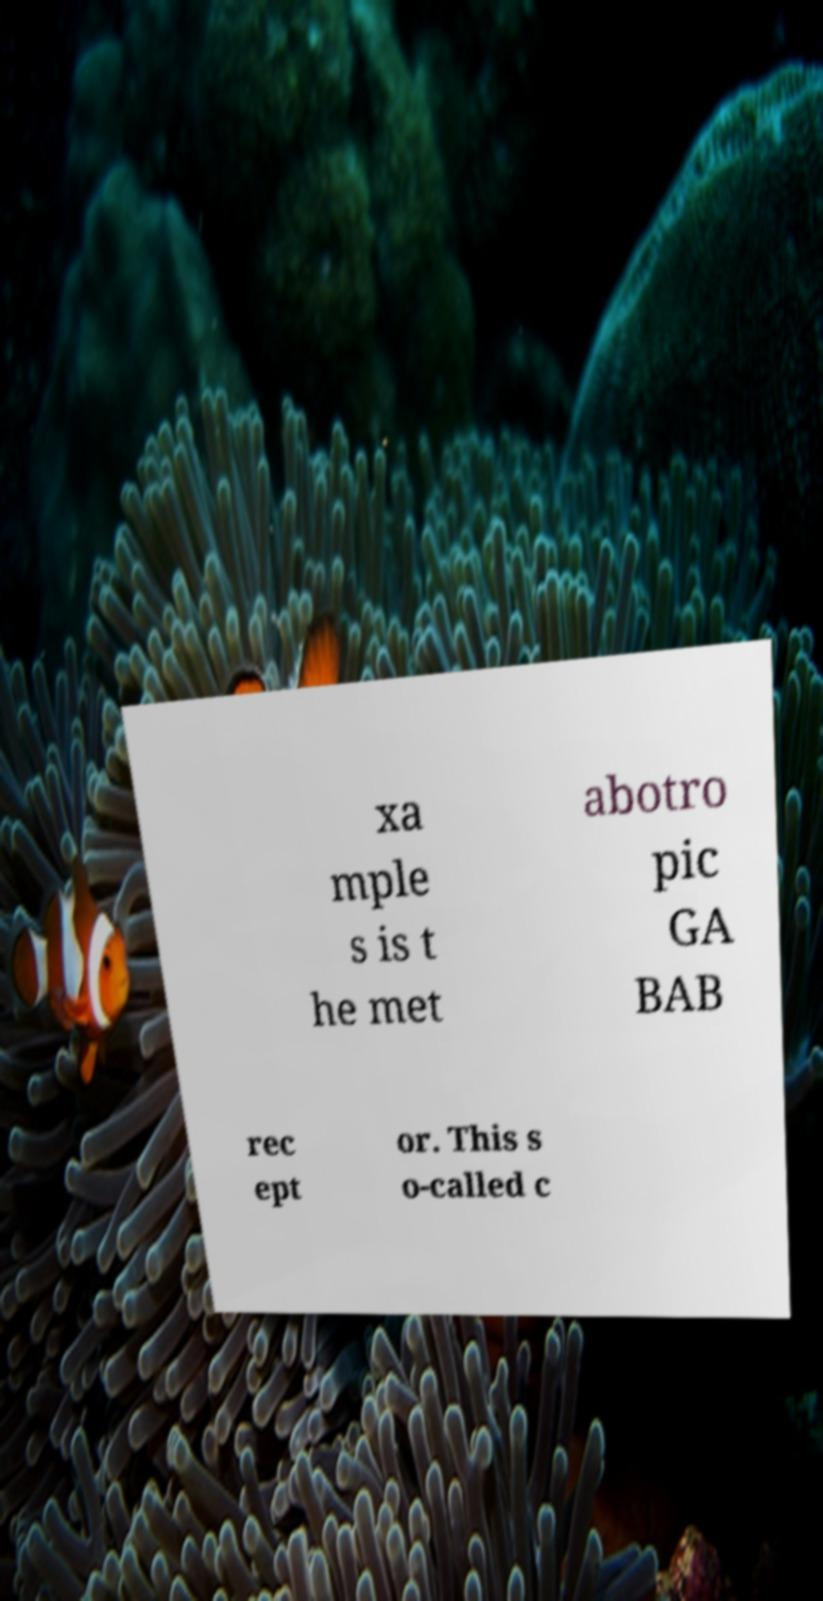There's text embedded in this image that I need extracted. Can you transcribe it verbatim? xa mple s is t he met abotro pic GA BAB rec ept or. This s o-called c 